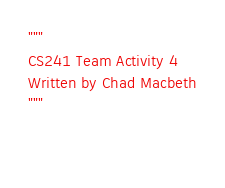Convert code to text. <code><loc_0><loc_0><loc_500><loc_500><_Python_>"""
CS241 Team Activity 4  
Written by Chad Macbeth
"""

   

</code> 